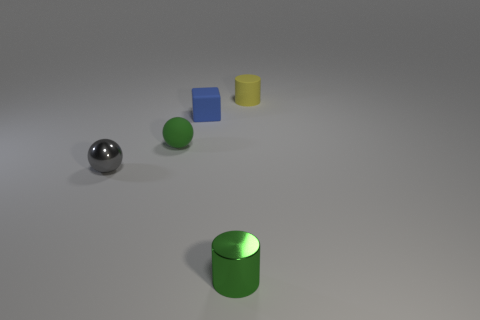Subtract all cylinders. How many objects are left? 3 Subtract 1 spheres. How many spheres are left? 1 Subtract all gray spheres. Subtract all green cubes. How many spheres are left? 1 Subtract all cyan blocks. How many red cylinders are left? 0 Subtract all big purple rubber balls. Subtract all small cubes. How many objects are left? 4 Add 4 small metallic objects. How many small metallic objects are left? 6 Add 1 tiny metallic balls. How many tiny metallic balls exist? 2 Add 3 gray rubber things. How many objects exist? 8 Subtract all green balls. How many balls are left? 1 Subtract 0 yellow balls. How many objects are left? 5 